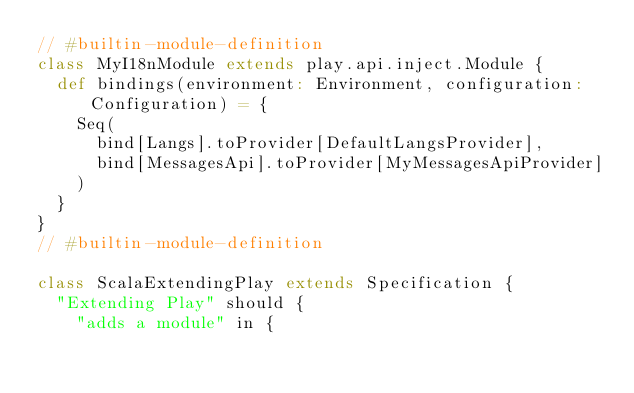<code> <loc_0><loc_0><loc_500><loc_500><_Scala_>// #builtin-module-definition
class MyI18nModule extends play.api.inject.Module {
  def bindings(environment: Environment, configuration: Configuration) = {
    Seq(
      bind[Langs].toProvider[DefaultLangsProvider],
      bind[MessagesApi].toProvider[MyMessagesApiProvider]
    )
  }
}
// #builtin-module-definition

class ScalaExtendingPlay extends Specification {
  "Extending Play" should {
    "adds a module" in {</code> 